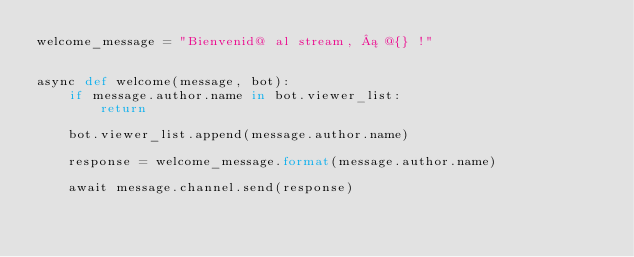Convert code to text. <code><loc_0><loc_0><loc_500><loc_500><_Python_>welcome_message = "Bienvenid@ al stream, ¡ @{} !"


async def welcome(message, bot):
    if message.author.name in bot.viewer_list:
        return

    bot.viewer_list.append(message.author.name)

    response = welcome_message.format(message.author.name)

    await message.channel.send(response)
</code> 